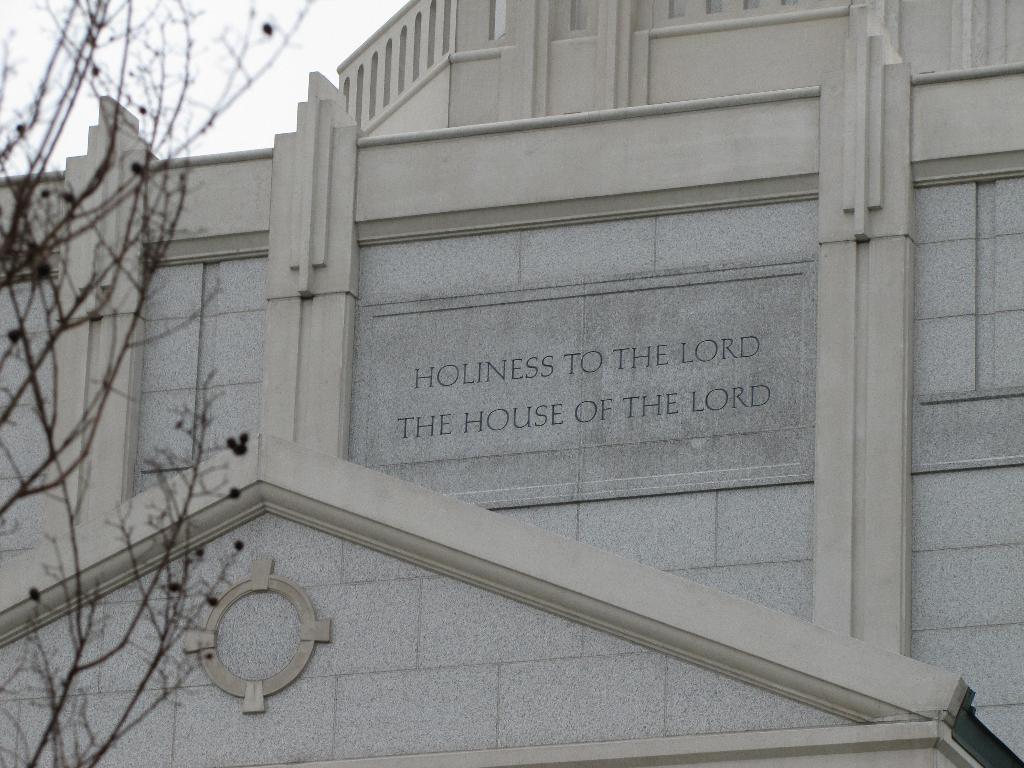Describe this image in one or two sentences. In this image, I can see the letters carved on a building wall. On the left side of the image, I can see a tree. In the background, there is the sky. 